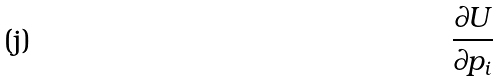<formula> <loc_0><loc_0><loc_500><loc_500>\frac { \partial U } { \partial p _ { i } }</formula> 